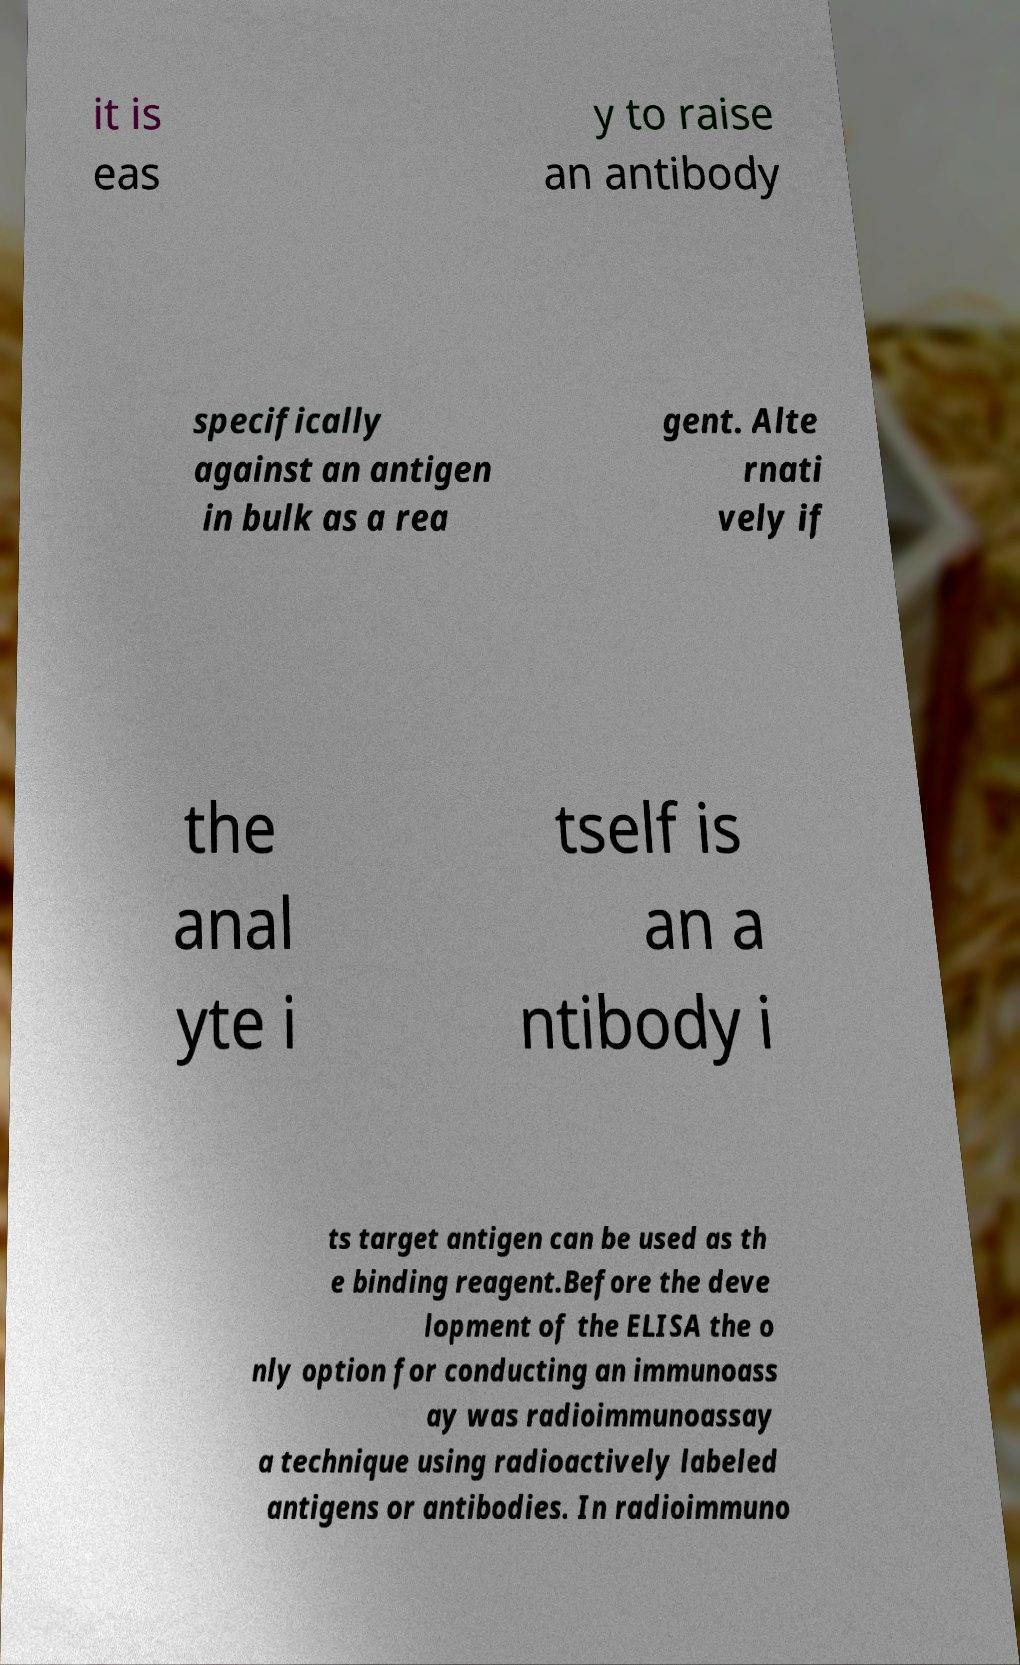Please read and relay the text visible in this image. What does it say? it is eas y to raise an antibody specifically against an antigen in bulk as a rea gent. Alte rnati vely if the anal yte i tself is an a ntibody i ts target antigen can be used as th e binding reagent.Before the deve lopment of the ELISA the o nly option for conducting an immunoass ay was radioimmunoassay a technique using radioactively labeled antigens or antibodies. In radioimmuno 